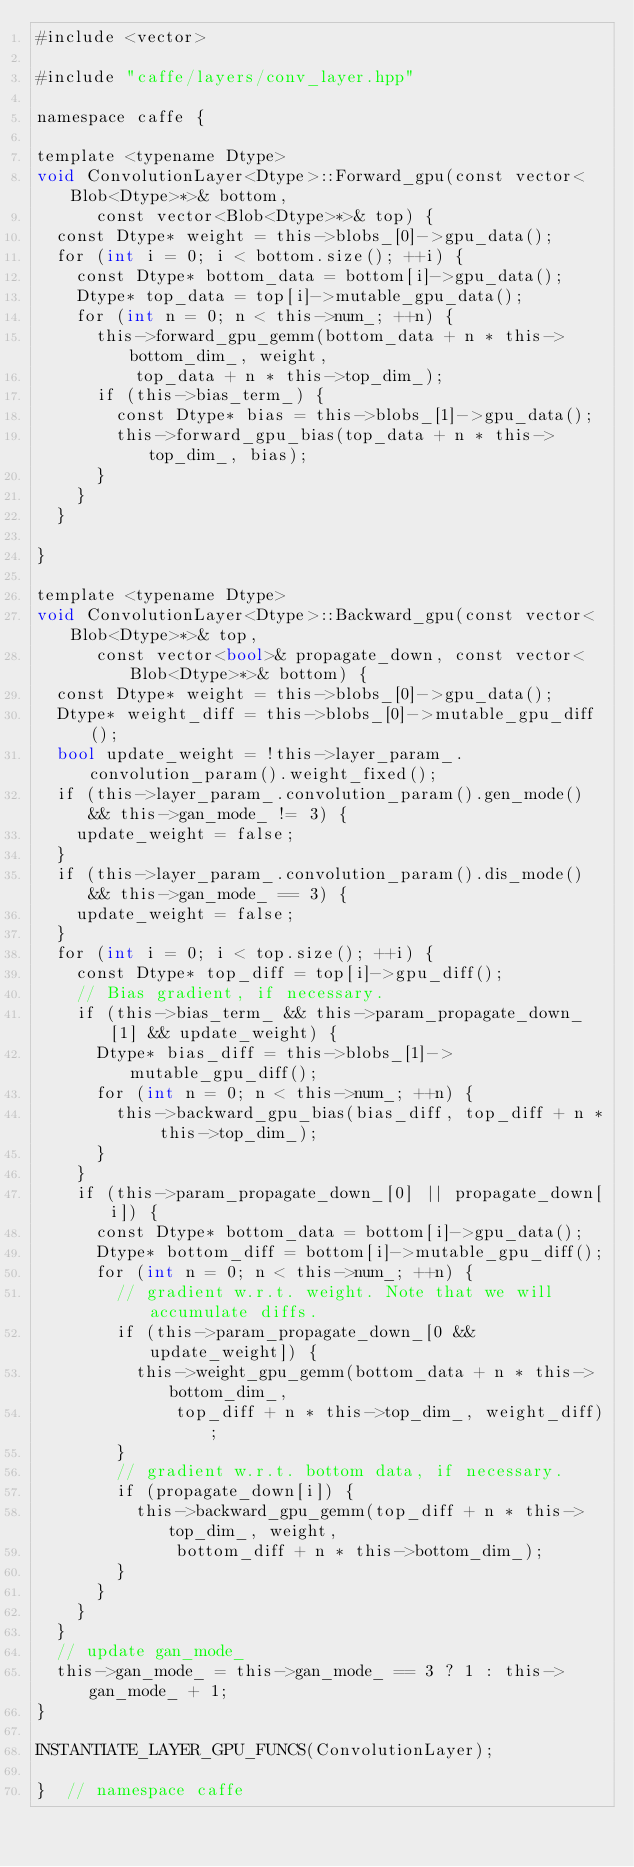<code> <loc_0><loc_0><loc_500><loc_500><_Cuda_>#include <vector>

#include "caffe/layers/conv_layer.hpp"

namespace caffe {

template <typename Dtype>
void ConvolutionLayer<Dtype>::Forward_gpu(const vector<Blob<Dtype>*>& bottom,
      const vector<Blob<Dtype>*>& top) {
  const Dtype* weight = this->blobs_[0]->gpu_data();
  for (int i = 0; i < bottom.size(); ++i) {
    const Dtype* bottom_data = bottom[i]->gpu_data();
    Dtype* top_data = top[i]->mutable_gpu_data();
    for (int n = 0; n < this->num_; ++n) {
      this->forward_gpu_gemm(bottom_data + n * this->bottom_dim_, weight,
          top_data + n * this->top_dim_);
      if (this->bias_term_) {
        const Dtype* bias = this->blobs_[1]->gpu_data();
        this->forward_gpu_bias(top_data + n * this->top_dim_, bias);
      }
    }
  }

}

template <typename Dtype>
void ConvolutionLayer<Dtype>::Backward_gpu(const vector<Blob<Dtype>*>& top,
      const vector<bool>& propagate_down, const vector<Blob<Dtype>*>& bottom) {
  const Dtype* weight = this->blobs_[0]->gpu_data();
  Dtype* weight_diff = this->blobs_[0]->mutable_gpu_diff();
  bool update_weight = !this->layer_param_.convolution_param().weight_fixed();
  if (this->layer_param_.convolution_param().gen_mode() && this->gan_mode_ != 3) {
	update_weight = false;
  }
  if (this->layer_param_.convolution_param().dis_mode() && this->gan_mode_ == 3) {
	update_weight = false;
  }
  for (int i = 0; i < top.size(); ++i) {
    const Dtype* top_diff = top[i]->gpu_diff();
    // Bias gradient, if necessary.
    if (this->bias_term_ && this->param_propagate_down_[1] && update_weight) {
      Dtype* bias_diff = this->blobs_[1]->mutable_gpu_diff();
      for (int n = 0; n < this->num_; ++n) {
        this->backward_gpu_bias(bias_diff, top_diff + n * this->top_dim_);
      }
    }
    if (this->param_propagate_down_[0] || propagate_down[i]) {
      const Dtype* bottom_data = bottom[i]->gpu_data();
      Dtype* bottom_diff = bottom[i]->mutable_gpu_diff();
      for (int n = 0; n < this->num_; ++n) {
        // gradient w.r.t. weight. Note that we will accumulate diffs.
        if (this->param_propagate_down_[0 && update_weight]) {
          this->weight_gpu_gemm(bottom_data + n * this->bottom_dim_,
              top_diff + n * this->top_dim_, weight_diff);
        }
        // gradient w.r.t. bottom data, if necessary.
        if (propagate_down[i]) {
          this->backward_gpu_gemm(top_diff + n * this->top_dim_, weight,
              bottom_diff + n * this->bottom_dim_);
        }
      }
    }
  }
  // update gan_mode_
  this->gan_mode_ = this->gan_mode_ == 3 ? 1 : this->gan_mode_ + 1;
}

INSTANTIATE_LAYER_GPU_FUNCS(ConvolutionLayer);

}  // namespace caffe
</code> 